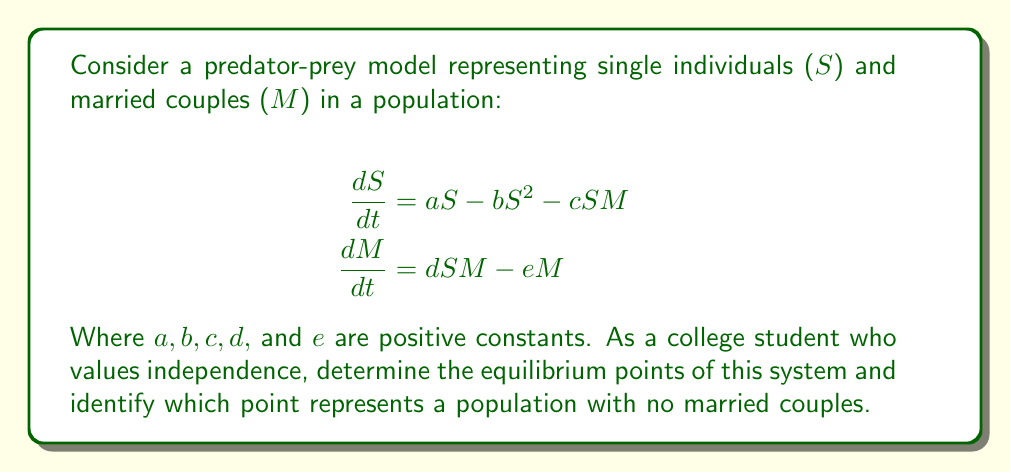Solve this math problem. To find the equilibrium points, we set both equations equal to zero and solve for S and M:

1) Set $\frac{dS}{dt} = 0$ and $\frac{dM}{dt} = 0$:

   $$aS - bS^2 - cSM = 0$$
   $$dSM - eM = 0$$

2) From the second equation:
   $$M(dS - e) = 0$$
   So either $M = 0$ or $S = \frac{e}{d}$

3) If $M = 0$, substitute into the first equation:
   $$aS - bS^2 = 0$$
   $$S(a - bS) = 0$$
   So either $S = 0$ or $S = \frac{a}{b}$

4) If $S = \frac{e}{d}$, substitute into the first equation:
   $$a\frac{e}{d} - b(\frac{e}{d})^2 - c\frac{e}{d}M = 0$$
   Solve for M:
   $$M = \frac{ae - be^2/d}{ce}$$

5) Therefore, we have three equilibrium points:
   (0, 0)
   $(\frac{a}{b}, 0)$
   $(\frac{e}{d}, \frac{ae - be^2/d}{ce})$

The point $(\frac{a}{b}, 0)$ represents a population with only single individuals and no married couples.
Answer: Equilibrium points: (0, 0), $(\frac{a}{b}, 0)$, $(\frac{e}{d}, \frac{ae - be^2/d}{ce})$. $(\frac{a}{b}, 0)$ represents no married couples. 